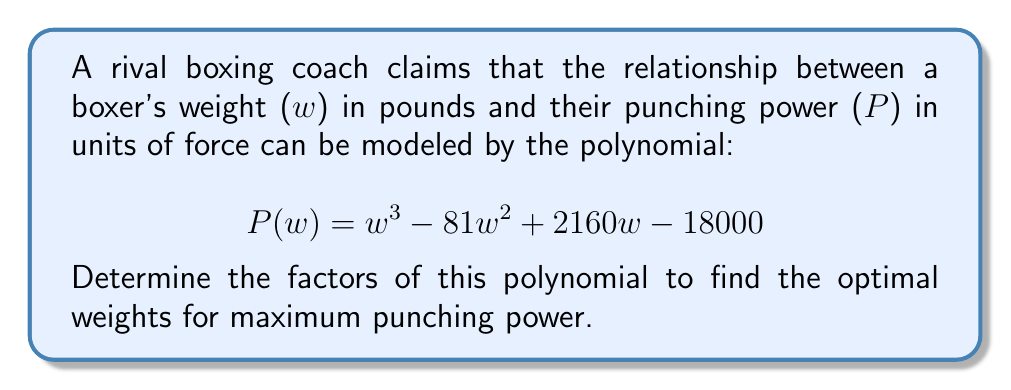Can you solve this math problem? To factor this polynomial, we'll follow these steps:

1) First, let's check if there are any rational roots using the rational root theorem. The possible rational roots are the factors of the constant term: ±1, ±2, ±3, ±4, ±5, ±6, ±9, ±10, ±12, ±15, ±18, ±20, ±30, ±36, ±45, ±60, ±90, ±100, ±180, ±300, ±900, ±1800, ±3600, ±18000

2) Testing these values, we find that 60 is a root. So $(w-60)$ is a factor.

3) Dividing $P(w)$ by $(w-60)$:

   $P(w) = (w-60)(w^2 - 21w + 300)$

4) Now we need to factor the quadratic $w^2 - 21w + 300$

5) The discriminant is $b^2 - 4ac = (-21)^2 - 4(1)(300) = 441 - 1200 = -759$

6) Since the discriminant is negative, this quadratic has no real roots. It can't be factored further over the real numbers.

Therefore, the complete factorization is:

$P(w) = (w-60)(w^2 - 21w + 300)$

The only real root is at $w=60$, which represents the optimal weight for maximum punching power according to this model.
Answer: $(w-60)(w^2 - 21w + 300)$ 